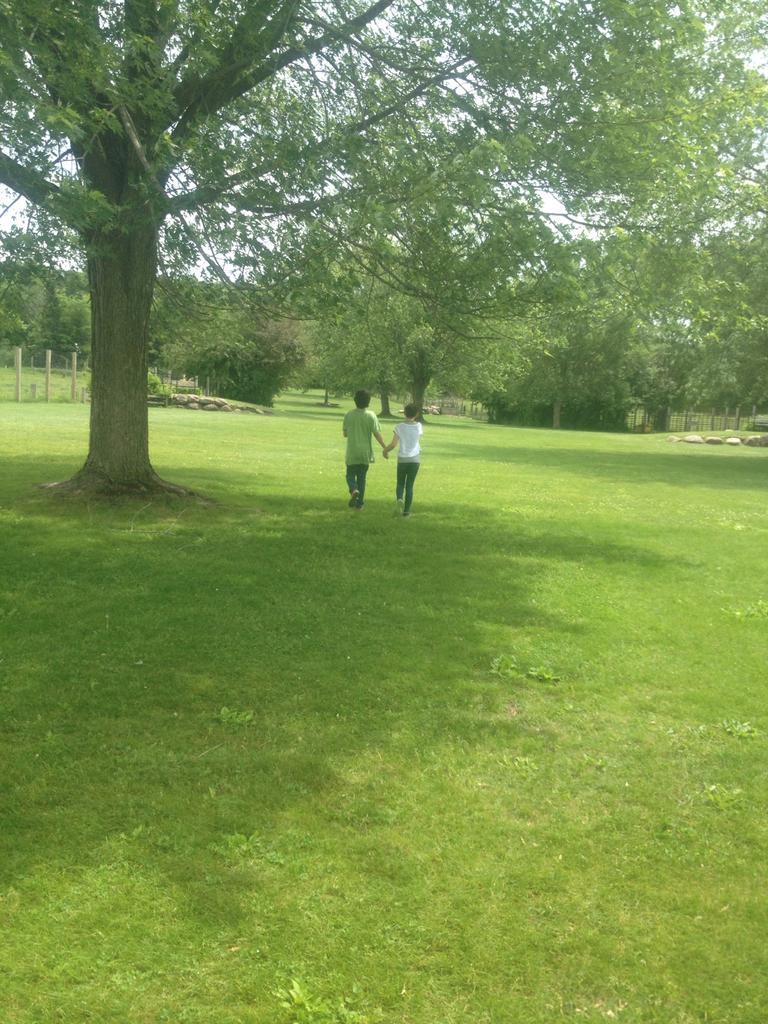What are the people in the image doing? The people in the image are walking. On what surface are the people walking? The people are walking on the ground. What can be seen in the background of the image? There are trees, stones, and a fence in the background of the image. How many sofas can be seen in the image? There are no sofas present in the image. Are there any slaves depicted in the image? There is no mention or depiction of slaves in the image. 